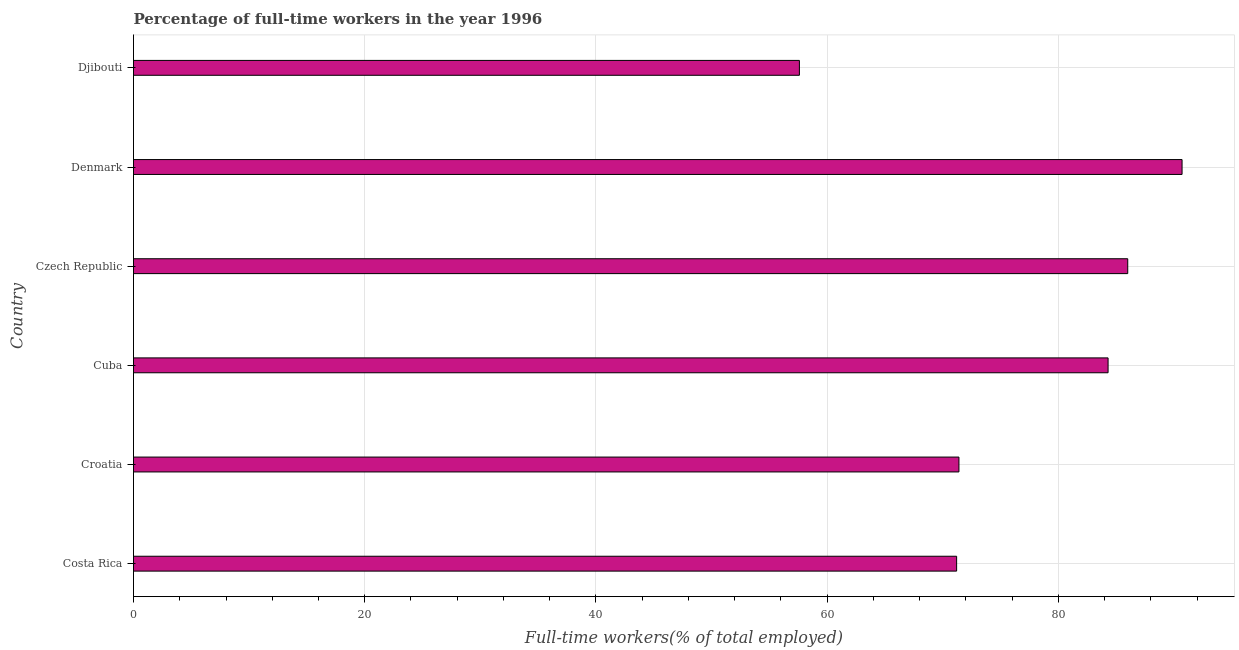What is the title of the graph?
Make the answer very short. Percentage of full-time workers in the year 1996. What is the label or title of the X-axis?
Offer a very short reply. Full-time workers(% of total employed). What is the percentage of full-time workers in Cuba?
Ensure brevity in your answer.  84.3. Across all countries, what is the maximum percentage of full-time workers?
Provide a succinct answer. 90.7. Across all countries, what is the minimum percentage of full-time workers?
Provide a succinct answer. 57.6. In which country was the percentage of full-time workers minimum?
Your answer should be compact. Djibouti. What is the sum of the percentage of full-time workers?
Offer a terse response. 461.2. What is the difference between the percentage of full-time workers in Cuba and Djibouti?
Offer a very short reply. 26.7. What is the average percentage of full-time workers per country?
Provide a short and direct response. 76.87. What is the median percentage of full-time workers?
Provide a succinct answer. 77.85. In how many countries, is the percentage of full-time workers greater than 4 %?
Your answer should be compact. 6. What is the ratio of the percentage of full-time workers in Costa Rica to that in Cuba?
Offer a very short reply. 0.84. What is the difference between the highest and the second highest percentage of full-time workers?
Provide a short and direct response. 4.7. What is the difference between the highest and the lowest percentage of full-time workers?
Make the answer very short. 33.1. How many countries are there in the graph?
Offer a very short reply. 6. What is the Full-time workers(% of total employed) in Costa Rica?
Offer a terse response. 71.2. What is the Full-time workers(% of total employed) of Croatia?
Provide a succinct answer. 71.4. What is the Full-time workers(% of total employed) in Cuba?
Your response must be concise. 84.3. What is the Full-time workers(% of total employed) in Czech Republic?
Give a very brief answer. 86. What is the Full-time workers(% of total employed) of Denmark?
Offer a very short reply. 90.7. What is the Full-time workers(% of total employed) in Djibouti?
Provide a short and direct response. 57.6. What is the difference between the Full-time workers(% of total employed) in Costa Rica and Cuba?
Give a very brief answer. -13.1. What is the difference between the Full-time workers(% of total employed) in Costa Rica and Czech Republic?
Offer a terse response. -14.8. What is the difference between the Full-time workers(% of total employed) in Costa Rica and Denmark?
Give a very brief answer. -19.5. What is the difference between the Full-time workers(% of total employed) in Croatia and Cuba?
Provide a short and direct response. -12.9. What is the difference between the Full-time workers(% of total employed) in Croatia and Czech Republic?
Make the answer very short. -14.6. What is the difference between the Full-time workers(% of total employed) in Croatia and Denmark?
Give a very brief answer. -19.3. What is the difference between the Full-time workers(% of total employed) in Cuba and Denmark?
Keep it short and to the point. -6.4. What is the difference between the Full-time workers(% of total employed) in Cuba and Djibouti?
Ensure brevity in your answer.  26.7. What is the difference between the Full-time workers(% of total employed) in Czech Republic and Djibouti?
Your answer should be compact. 28.4. What is the difference between the Full-time workers(% of total employed) in Denmark and Djibouti?
Offer a terse response. 33.1. What is the ratio of the Full-time workers(% of total employed) in Costa Rica to that in Cuba?
Offer a very short reply. 0.84. What is the ratio of the Full-time workers(% of total employed) in Costa Rica to that in Czech Republic?
Give a very brief answer. 0.83. What is the ratio of the Full-time workers(% of total employed) in Costa Rica to that in Denmark?
Your response must be concise. 0.79. What is the ratio of the Full-time workers(% of total employed) in Costa Rica to that in Djibouti?
Your answer should be compact. 1.24. What is the ratio of the Full-time workers(% of total employed) in Croatia to that in Cuba?
Make the answer very short. 0.85. What is the ratio of the Full-time workers(% of total employed) in Croatia to that in Czech Republic?
Your response must be concise. 0.83. What is the ratio of the Full-time workers(% of total employed) in Croatia to that in Denmark?
Provide a succinct answer. 0.79. What is the ratio of the Full-time workers(% of total employed) in Croatia to that in Djibouti?
Make the answer very short. 1.24. What is the ratio of the Full-time workers(% of total employed) in Cuba to that in Czech Republic?
Provide a succinct answer. 0.98. What is the ratio of the Full-time workers(% of total employed) in Cuba to that in Denmark?
Your answer should be compact. 0.93. What is the ratio of the Full-time workers(% of total employed) in Cuba to that in Djibouti?
Ensure brevity in your answer.  1.46. What is the ratio of the Full-time workers(% of total employed) in Czech Republic to that in Denmark?
Provide a short and direct response. 0.95. What is the ratio of the Full-time workers(% of total employed) in Czech Republic to that in Djibouti?
Ensure brevity in your answer.  1.49. What is the ratio of the Full-time workers(% of total employed) in Denmark to that in Djibouti?
Provide a succinct answer. 1.57. 